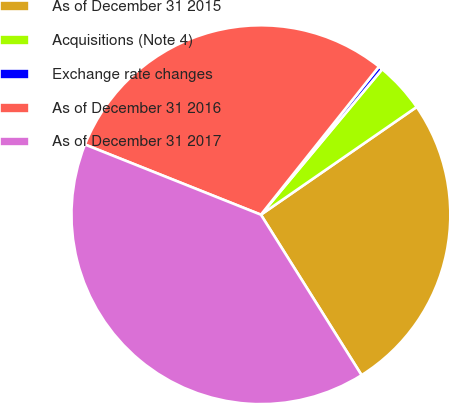Convert chart. <chart><loc_0><loc_0><loc_500><loc_500><pie_chart><fcel>As of December 31 2015<fcel>Acquisitions (Note 4)<fcel>Exchange rate changes<fcel>As of December 31 2016<fcel>As of December 31 2017<nl><fcel>25.71%<fcel>4.31%<fcel>0.35%<fcel>29.67%<fcel>39.96%<nl></chart> 